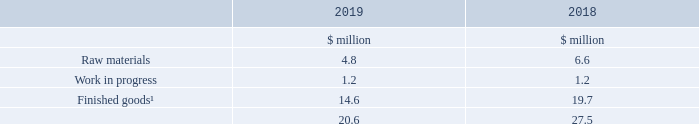19. Inventories
Note
1. Finished goods in 2018 includes $1.8 million relating to deferred costs which has been reclassified from trade and other receivables; see note 2 for further details.
An expense of $1.6 million (2018 $0.1 million) has been charged to the income statement in the year for inventory write-downs. There were no reversals of prior period inventory write-downs (2018 nil).
No inventories are carried at fair value less costs to sell (2018 nil).
What does Finished goods in 2018 include? $1.8 million relating to deferred costs which has been reclassified from trade and other receivables. What was charged to the income statement in the year for inventory write-downs? An expense of $1.6 million (2018 $0.1 million). What are the types of inventories in the table? Raw materials, work in progress, finished goods. In which year was the amount of raw materials larger? 6.6>4.8
Answer: 2018. What was the change in total inventories?
Answer scale should be: million. 20.6-27.5
Answer: -6.9. What was the percentage change in total inventories?
Answer scale should be: percent. (20.6-27.5)/27.5
Answer: -25.09. 